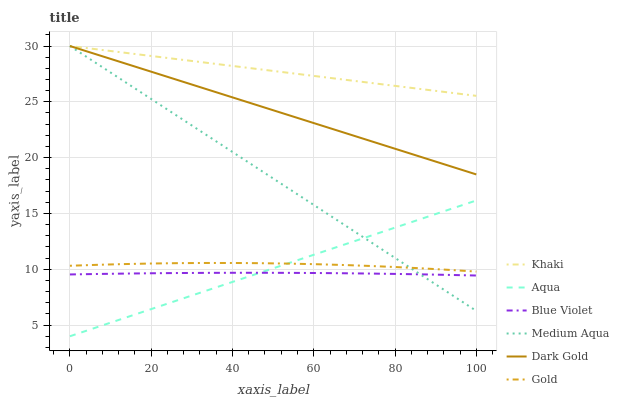Does Gold have the minimum area under the curve?
Answer yes or no. No. Does Gold have the maximum area under the curve?
Answer yes or no. No. Is Gold the smoothest?
Answer yes or no. No. Is Dark Gold the roughest?
Answer yes or no. No. Does Gold have the lowest value?
Answer yes or no. No. Does Gold have the highest value?
Answer yes or no. No. Is Aqua less than Khaki?
Answer yes or no. Yes. Is Dark Gold greater than Gold?
Answer yes or no. Yes. Does Aqua intersect Khaki?
Answer yes or no. No. 